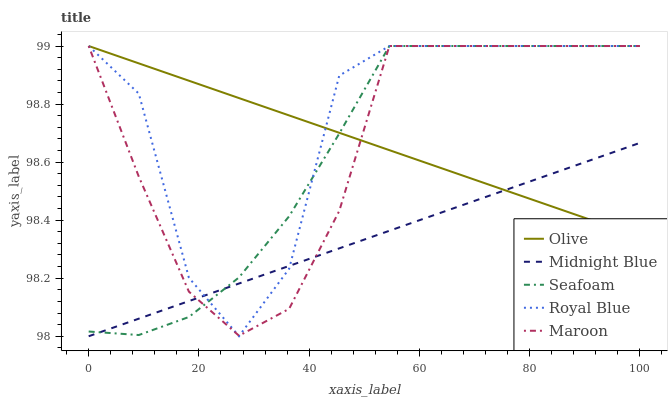Does Midnight Blue have the minimum area under the curve?
Answer yes or no. Yes. Does Royal Blue have the maximum area under the curve?
Answer yes or no. Yes. Does Royal Blue have the minimum area under the curve?
Answer yes or no. No. Does Midnight Blue have the maximum area under the curve?
Answer yes or no. No. Is Midnight Blue the smoothest?
Answer yes or no. Yes. Is Royal Blue the roughest?
Answer yes or no. Yes. Is Royal Blue the smoothest?
Answer yes or no. No. Is Midnight Blue the roughest?
Answer yes or no. No. Does Midnight Blue have the lowest value?
Answer yes or no. Yes. Does Royal Blue have the lowest value?
Answer yes or no. No. Does Seafoam have the highest value?
Answer yes or no. Yes. Does Midnight Blue have the highest value?
Answer yes or no. No. Does Midnight Blue intersect Seafoam?
Answer yes or no. Yes. Is Midnight Blue less than Seafoam?
Answer yes or no. No. Is Midnight Blue greater than Seafoam?
Answer yes or no. No. 